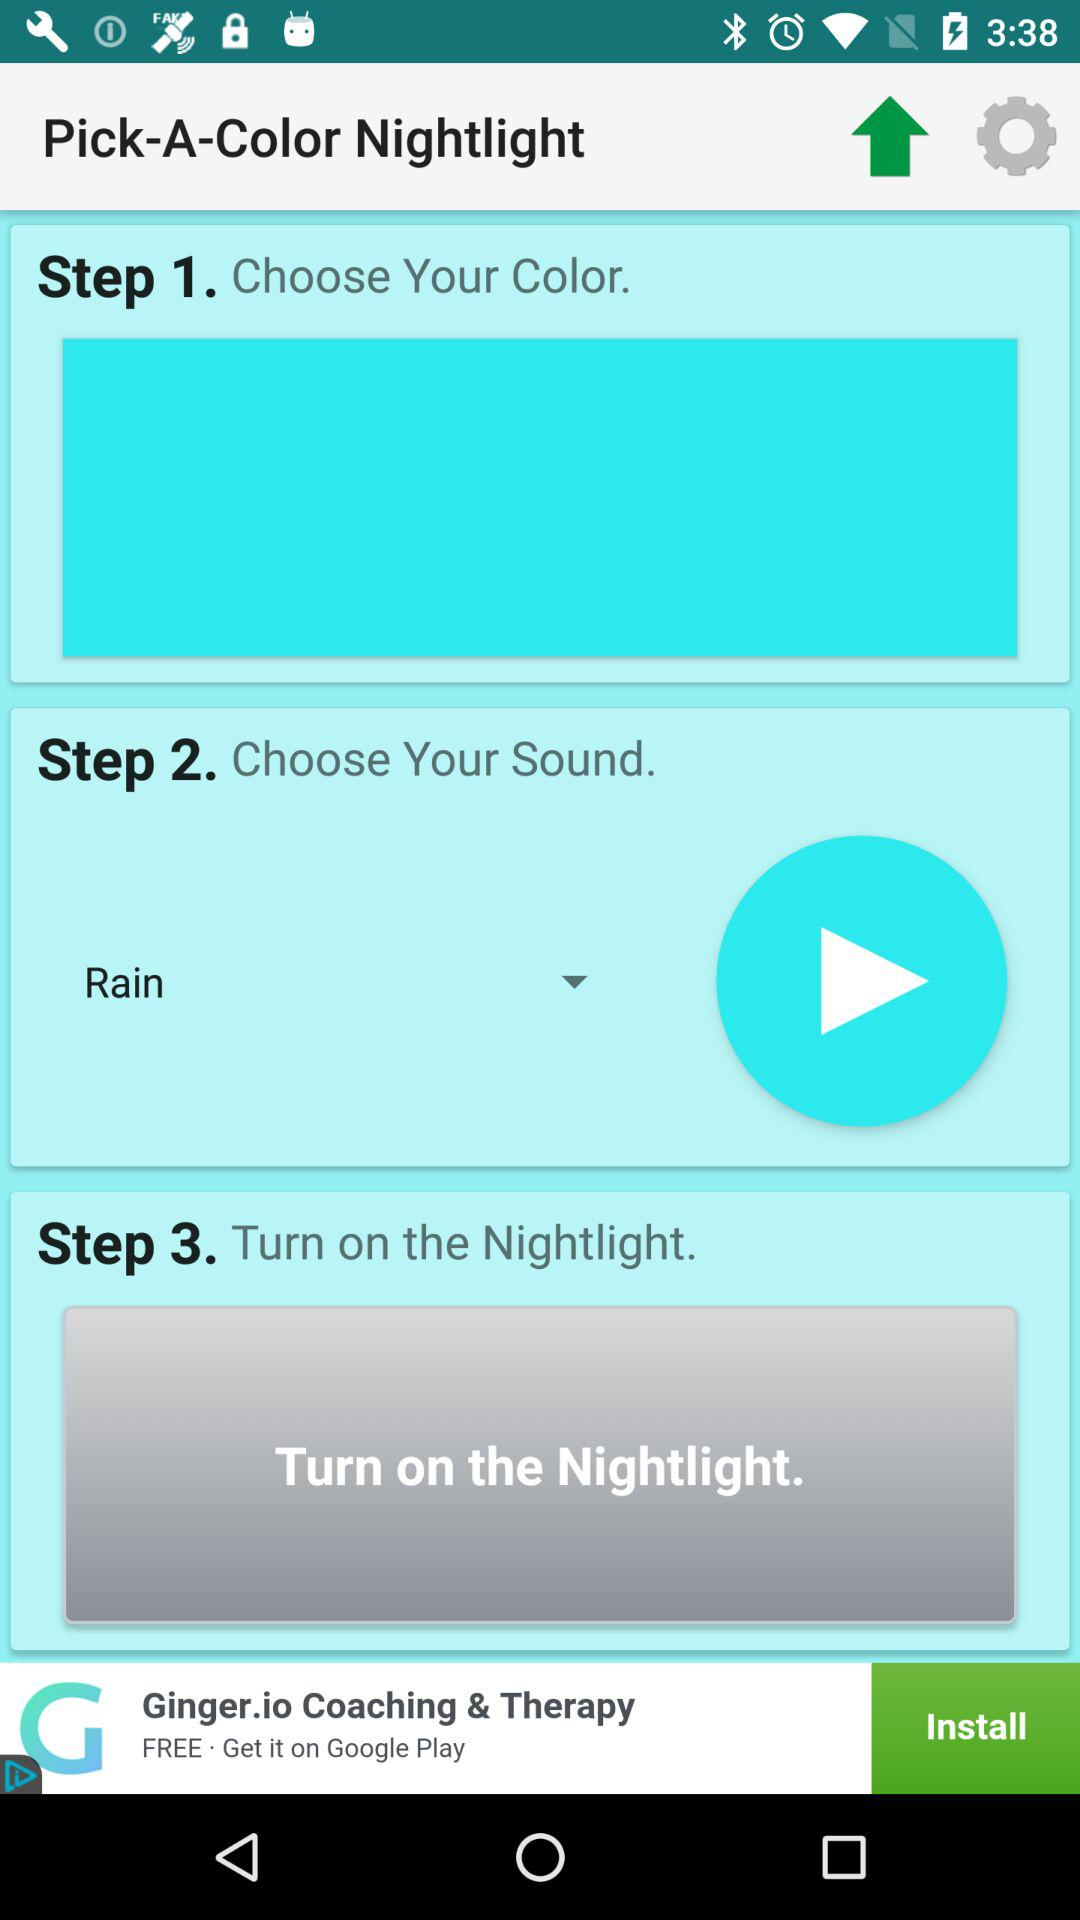Which sound is selected? The selected sound is "Rain". 